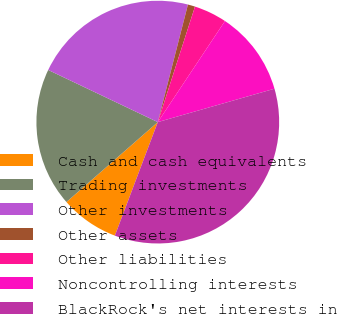Convert chart. <chart><loc_0><loc_0><loc_500><loc_500><pie_chart><fcel>Cash and cash equivalents<fcel>Trading investments<fcel>Other investments<fcel>Other assets<fcel>Other liabilities<fcel>Noncontrolling interests<fcel>BlackRock's net interests in<nl><fcel>7.81%<fcel>18.51%<fcel>21.93%<fcel>0.96%<fcel>4.38%<fcel>11.23%<fcel>35.19%<nl></chart> 